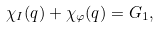<formula> <loc_0><loc_0><loc_500><loc_500>\chi _ { I } ( q ) + \chi _ { \varphi } ( q ) = G _ { 1 } ,</formula> 